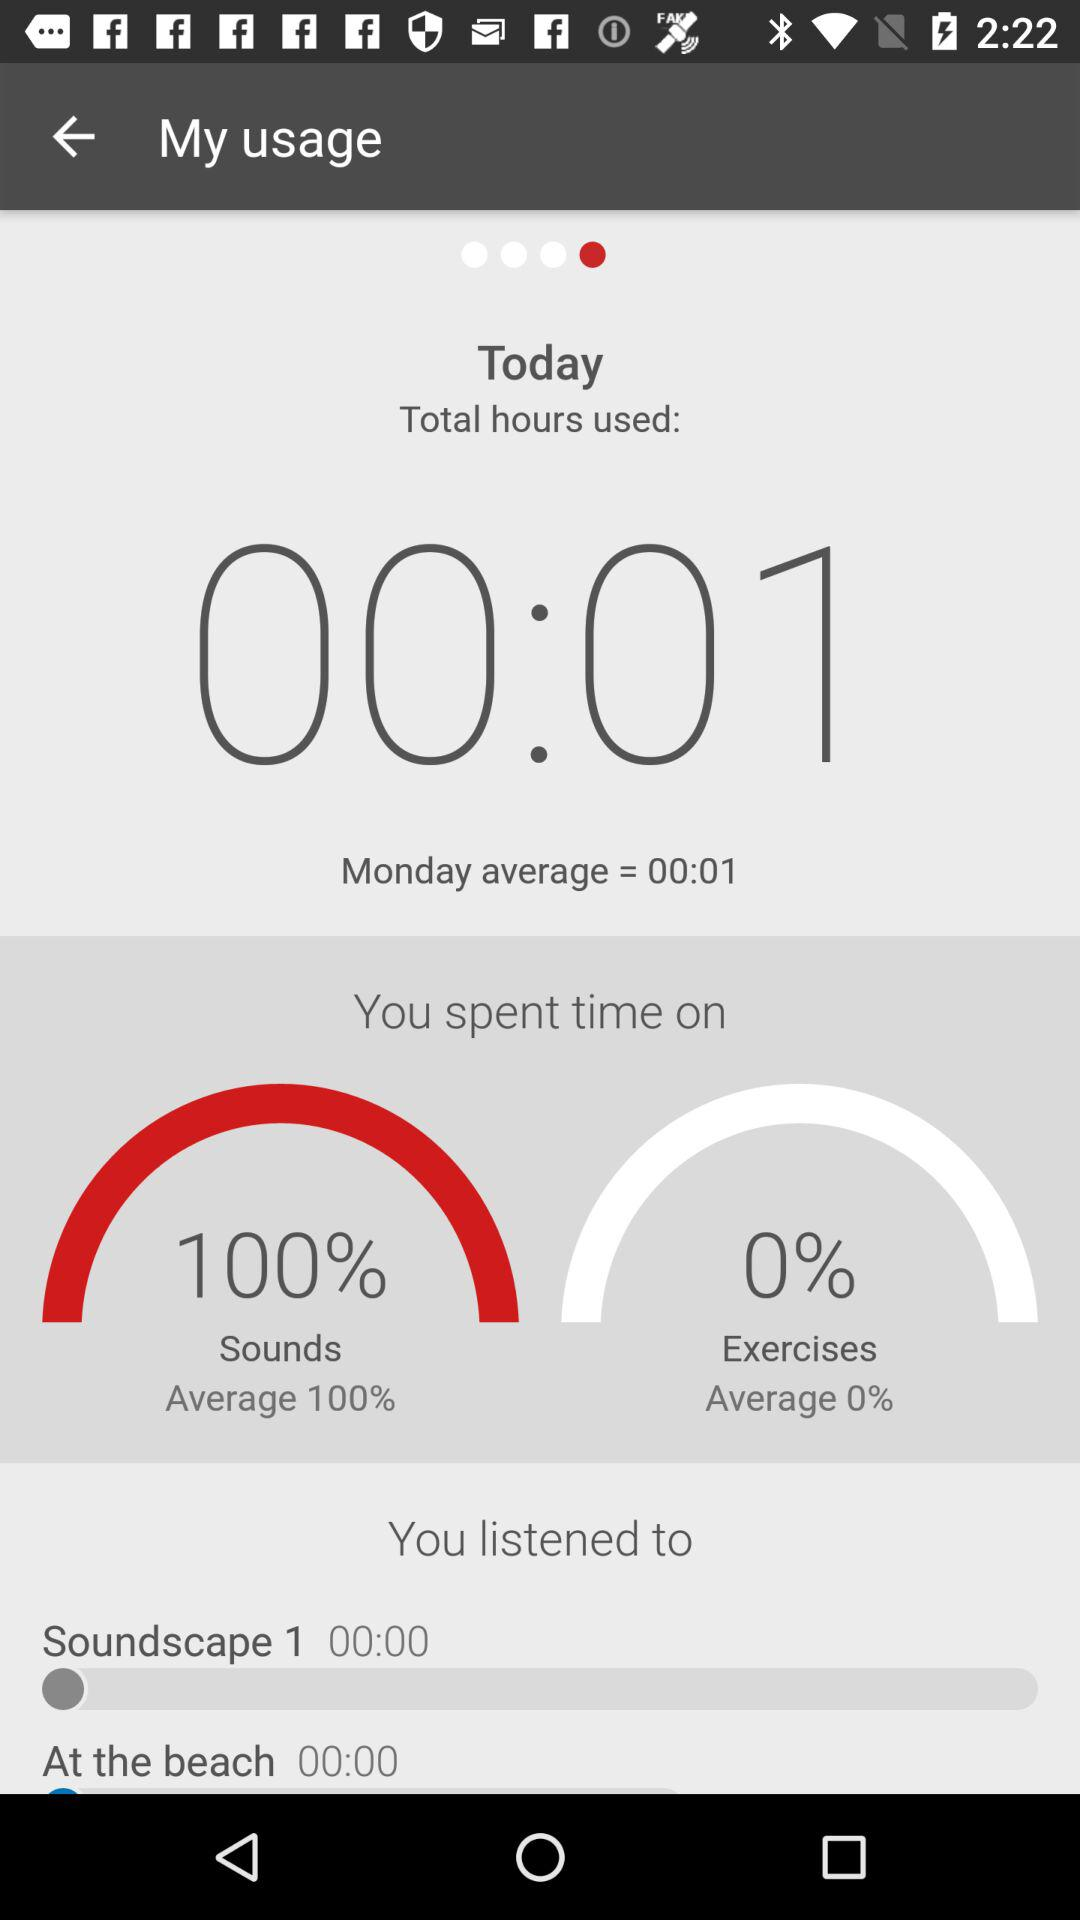What's the average number of total hours used on Monday? The average number of total hours used on Monday is 00:01. 